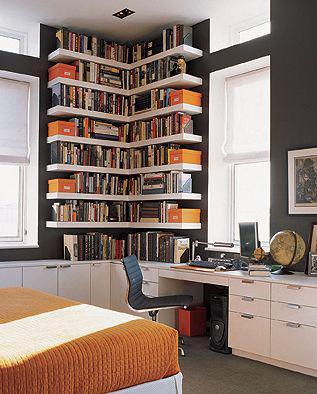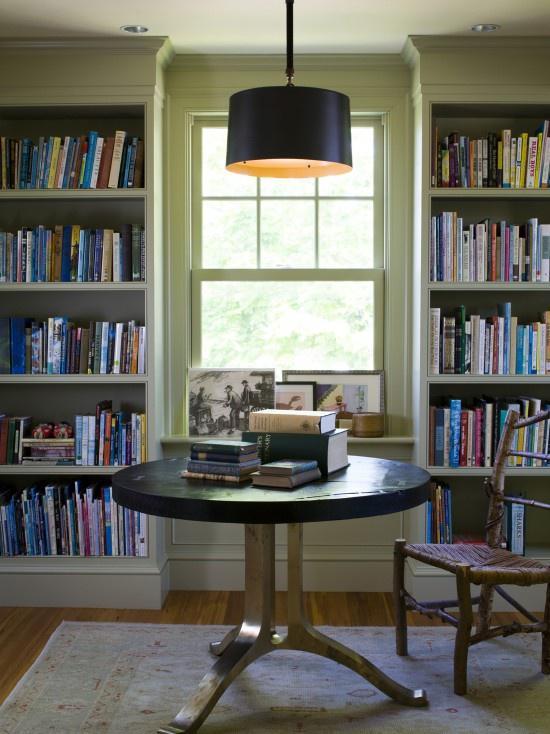The first image is the image on the left, the second image is the image on the right. Analyze the images presented: Is the assertion "A light fixture is suspended at the center of the room in the right image." valid? Answer yes or no. Yes. The first image is the image on the left, the second image is the image on the right. For the images shown, is this caption "In one image, floor to ceiling shelving units flank a fire place." true? Answer yes or no. No. 